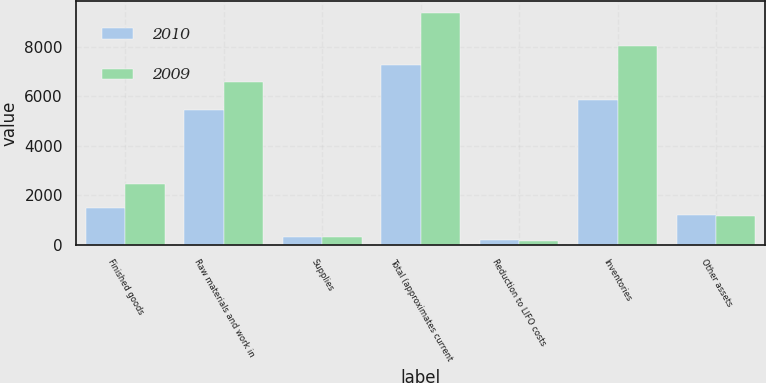Convert chart. <chart><loc_0><loc_0><loc_500><loc_500><stacked_bar_chart><ecel><fcel>Finished goods<fcel>Raw materials and work in<fcel>Supplies<fcel>Total (approximates current<fcel>Reduction to LIFO costs<fcel>Inventories<fcel>Other assets<nl><fcel>2010<fcel>1484<fcel>5449<fcel>315<fcel>7248<fcel>186<fcel>5868<fcel>1194<nl><fcel>2009<fcel>2466<fcel>6583<fcel>323<fcel>9372<fcel>167<fcel>8048<fcel>1157<nl></chart> 